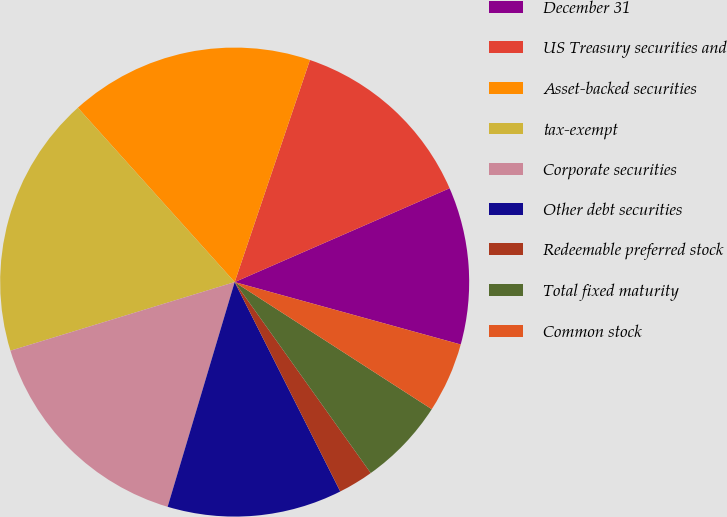Convert chart. <chart><loc_0><loc_0><loc_500><loc_500><pie_chart><fcel>December 31<fcel>US Treasury securities and<fcel>Asset-backed securities<fcel>tax-exempt<fcel>Corporate securities<fcel>Other debt securities<fcel>Redeemable preferred stock<fcel>Total fixed maturity<fcel>Common stock<nl><fcel>10.84%<fcel>13.25%<fcel>16.86%<fcel>18.07%<fcel>15.66%<fcel>12.05%<fcel>2.42%<fcel>6.03%<fcel>4.83%<nl></chart> 